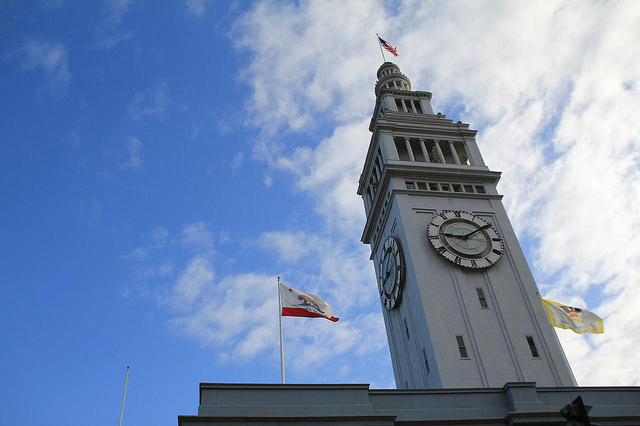<image>What kind of flags are these? It is unknown what kind of flags these are. They could be state, country, or government flags. What kind of flags are these? I don't know what kind of flags these are. They can be state, country, or government flags. 